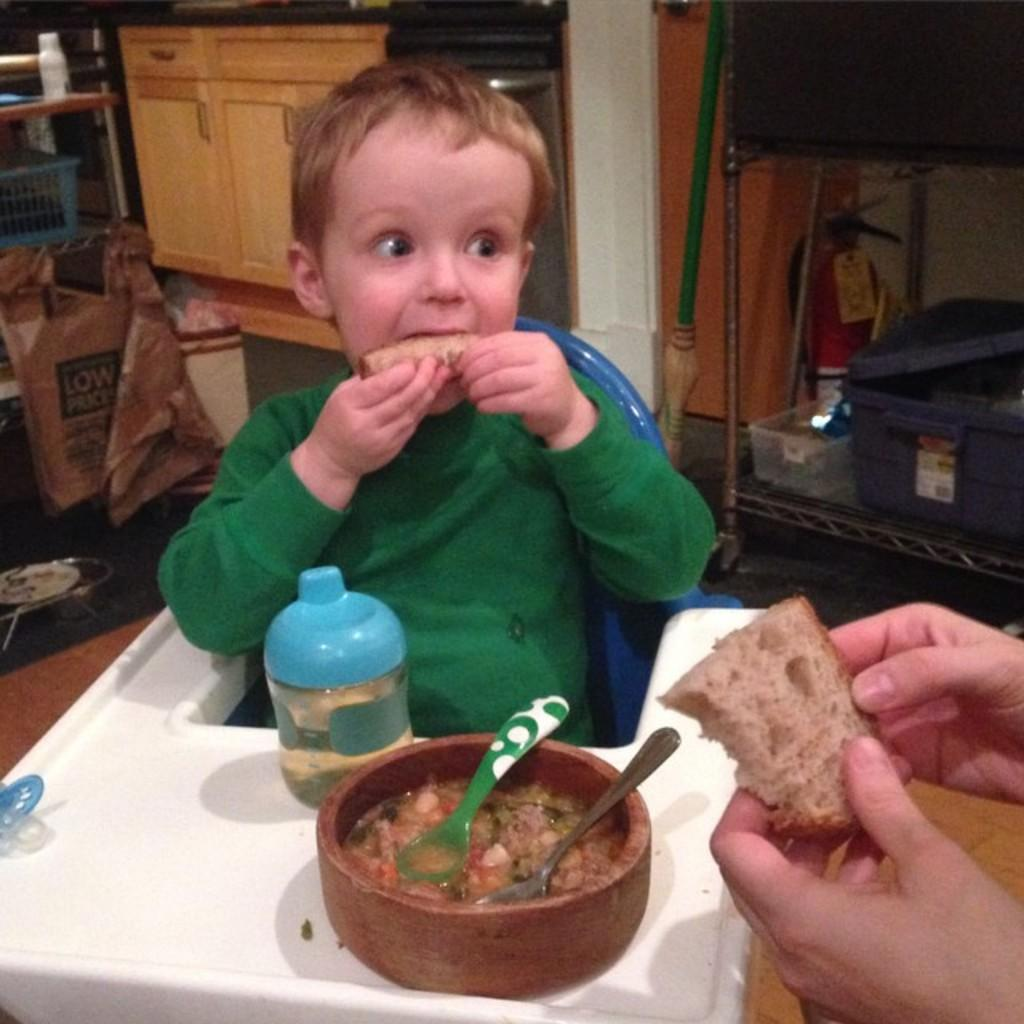What is the main subject of the image? The main subject of the image is a kid. What is the kid wearing? The kid is wearing a green shirt. What is the kid holding in the image? The kid has some bread. What else can be seen in the image besides the kid? There is food visible in the image, and there is a baby sipper present. How many ladybugs can be seen crawling on the kid's green shirt in the image? There are no ladybugs visible on the kid's green shirt in the image. What type of cup is the kid holding in the image? The image does not show the kid holding a cup; they are holding bread. 